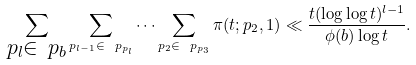Convert formula to latex. <formula><loc_0><loc_0><loc_500><loc_500>\sum _ { \substack { p _ { l } \in \ p _ { b } } } \sum _ { p _ { l - 1 } \in \ p _ { p _ { l } } } \dots \sum _ { p _ { 2 } \in \ p _ { p _ { 3 } } } \pi ( t ; p _ { 2 } , 1 ) \ll \frac { t ( \log \log t ) ^ { l - 1 } } { \phi ( b ) \log t } .</formula> 